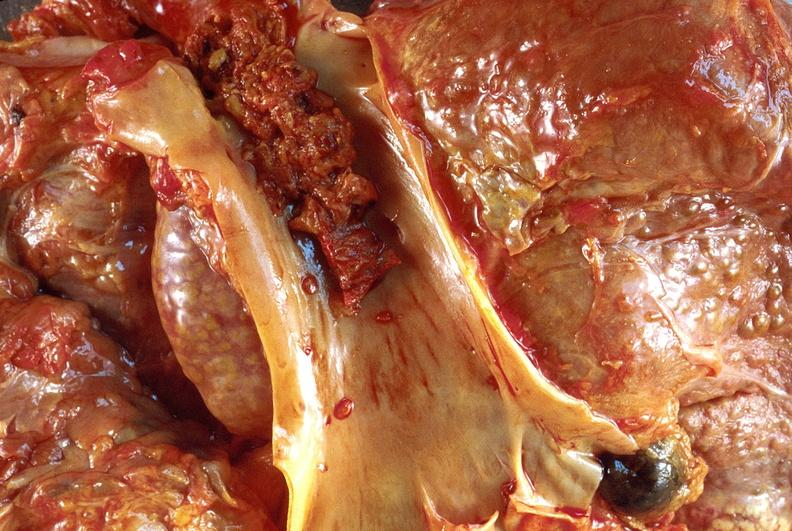s intramural one lesion present?
Answer the question using a single word or phrase. No 